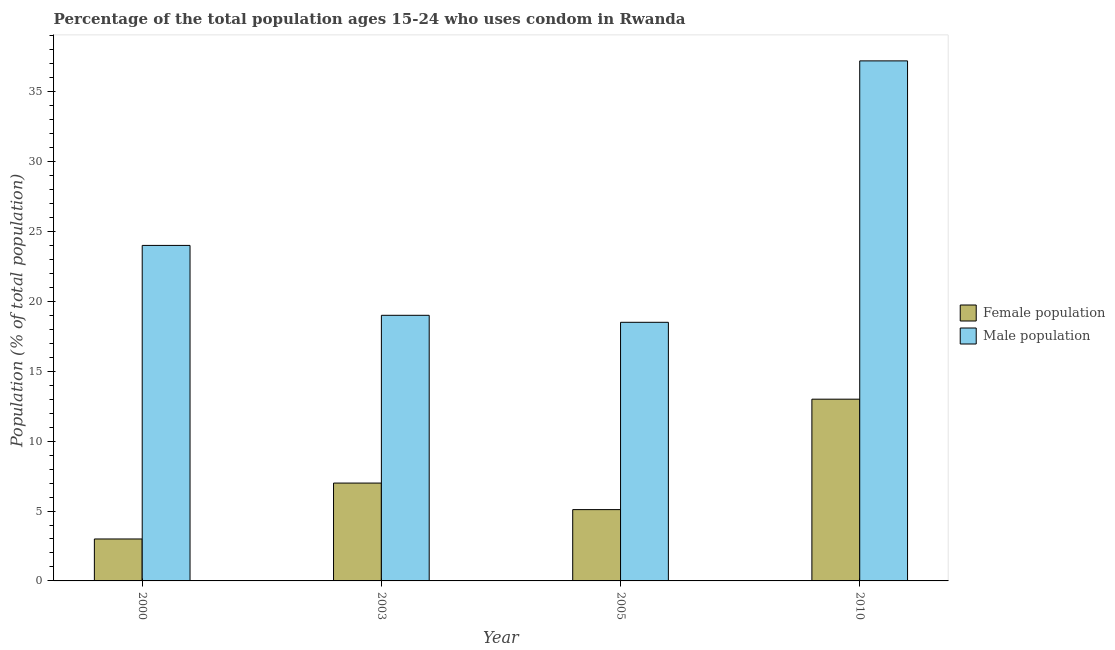Are the number of bars on each tick of the X-axis equal?
Make the answer very short. Yes. How many bars are there on the 2nd tick from the right?
Your answer should be compact. 2. What is the label of the 2nd group of bars from the left?
Your response must be concise. 2003. In how many cases, is the number of bars for a given year not equal to the number of legend labels?
Ensure brevity in your answer.  0. Across all years, what is the maximum female population?
Provide a short and direct response. 13. In which year was the male population maximum?
Your answer should be very brief. 2010. What is the total female population in the graph?
Offer a very short reply. 28.1. What is the difference between the female population in 2005 and the male population in 2000?
Ensure brevity in your answer.  2.1. What is the average male population per year?
Ensure brevity in your answer.  24.68. What is the ratio of the male population in 2000 to that in 2003?
Offer a very short reply. 1.26. Is the female population in 2000 less than that in 2010?
Ensure brevity in your answer.  Yes. Is the difference between the male population in 2003 and 2010 greater than the difference between the female population in 2003 and 2010?
Your response must be concise. No. What is the difference between the highest and the second highest male population?
Your answer should be compact. 13.2. What is the difference between the highest and the lowest male population?
Your answer should be very brief. 18.7. Is the sum of the male population in 2003 and 2005 greater than the maximum female population across all years?
Give a very brief answer. Yes. What does the 1st bar from the left in 2010 represents?
Offer a terse response. Female population. What does the 2nd bar from the right in 2003 represents?
Give a very brief answer. Female population. How many bars are there?
Your answer should be compact. 8. Are all the bars in the graph horizontal?
Your answer should be compact. No. How many years are there in the graph?
Provide a succinct answer. 4. Are the values on the major ticks of Y-axis written in scientific E-notation?
Offer a very short reply. No. Does the graph contain any zero values?
Your response must be concise. No. Does the graph contain grids?
Your answer should be compact. No. How many legend labels are there?
Provide a short and direct response. 2. What is the title of the graph?
Your answer should be very brief. Percentage of the total population ages 15-24 who uses condom in Rwanda. What is the label or title of the X-axis?
Offer a terse response. Year. What is the label or title of the Y-axis?
Ensure brevity in your answer.  Population (% of total population) . What is the Population (% of total population)  in Female population in 2000?
Offer a terse response. 3. What is the Population (% of total population)  of Male population in 2003?
Provide a short and direct response. 19. What is the Population (% of total population)  in Female population in 2005?
Provide a succinct answer. 5.1. What is the Population (% of total population)  of Male population in 2005?
Provide a short and direct response. 18.5. What is the Population (% of total population)  of Female population in 2010?
Your answer should be very brief. 13. What is the Population (% of total population)  in Male population in 2010?
Keep it short and to the point. 37.2. Across all years, what is the maximum Population (% of total population)  in Male population?
Your response must be concise. 37.2. Across all years, what is the minimum Population (% of total population)  of Female population?
Make the answer very short. 3. What is the total Population (% of total population)  of Female population in the graph?
Your answer should be very brief. 28.1. What is the total Population (% of total population)  in Male population in the graph?
Make the answer very short. 98.7. What is the difference between the Population (% of total population)  in Female population in 2000 and that in 2003?
Ensure brevity in your answer.  -4. What is the difference between the Population (% of total population)  in Female population in 2000 and that in 2005?
Your response must be concise. -2.1. What is the difference between the Population (% of total population)  in Male population in 2000 and that in 2005?
Your answer should be very brief. 5.5. What is the difference between the Population (% of total population)  in Male population in 2003 and that in 2005?
Your answer should be compact. 0.5. What is the difference between the Population (% of total population)  in Female population in 2003 and that in 2010?
Give a very brief answer. -6. What is the difference between the Population (% of total population)  in Male population in 2003 and that in 2010?
Offer a very short reply. -18.2. What is the difference between the Population (% of total population)  in Female population in 2005 and that in 2010?
Offer a very short reply. -7.9. What is the difference between the Population (% of total population)  in Male population in 2005 and that in 2010?
Offer a terse response. -18.7. What is the difference between the Population (% of total population)  in Female population in 2000 and the Population (% of total population)  in Male population in 2003?
Offer a terse response. -16. What is the difference between the Population (% of total population)  of Female population in 2000 and the Population (% of total population)  of Male population in 2005?
Provide a short and direct response. -15.5. What is the difference between the Population (% of total population)  in Female population in 2000 and the Population (% of total population)  in Male population in 2010?
Your response must be concise. -34.2. What is the difference between the Population (% of total population)  in Female population in 2003 and the Population (% of total population)  in Male population in 2005?
Your answer should be very brief. -11.5. What is the difference between the Population (% of total population)  in Female population in 2003 and the Population (% of total population)  in Male population in 2010?
Ensure brevity in your answer.  -30.2. What is the difference between the Population (% of total population)  in Female population in 2005 and the Population (% of total population)  in Male population in 2010?
Offer a terse response. -32.1. What is the average Population (% of total population)  of Female population per year?
Provide a succinct answer. 7.03. What is the average Population (% of total population)  in Male population per year?
Your answer should be very brief. 24.68. In the year 2003, what is the difference between the Population (% of total population)  of Female population and Population (% of total population)  of Male population?
Your response must be concise. -12. In the year 2010, what is the difference between the Population (% of total population)  of Female population and Population (% of total population)  of Male population?
Give a very brief answer. -24.2. What is the ratio of the Population (% of total population)  in Female population in 2000 to that in 2003?
Ensure brevity in your answer.  0.43. What is the ratio of the Population (% of total population)  in Male population in 2000 to that in 2003?
Your answer should be compact. 1.26. What is the ratio of the Population (% of total population)  of Female population in 2000 to that in 2005?
Provide a short and direct response. 0.59. What is the ratio of the Population (% of total population)  of Male population in 2000 to that in 2005?
Offer a very short reply. 1.3. What is the ratio of the Population (% of total population)  in Female population in 2000 to that in 2010?
Keep it short and to the point. 0.23. What is the ratio of the Population (% of total population)  of Male population in 2000 to that in 2010?
Your answer should be very brief. 0.65. What is the ratio of the Population (% of total population)  in Female population in 2003 to that in 2005?
Keep it short and to the point. 1.37. What is the ratio of the Population (% of total population)  of Male population in 2003 to that in 2005?
Give a very brief answer. 1.03. What is the ratio of the Population (% of total population)  in Female population in 2003 to that in 2010?
Your response must be concise. 0.54. What is the ratio of the Population (% of total population)  in Male population in 2003 to that in 2010?
Give a very brief answer. 0.51. What is the ratio of the Population (% of total population)  of Female population in 2005 to that in 2010?
Provide a succinct answer. 0.39. What is the ratio of the Population (% of total population)  of Male population in 2005 to that in 2010?
Give a very brief answer. 0.5. What is the difference between the highest and the lowest Population (% of total population)  of Male population?
Offer a very short reply. 18.7. 